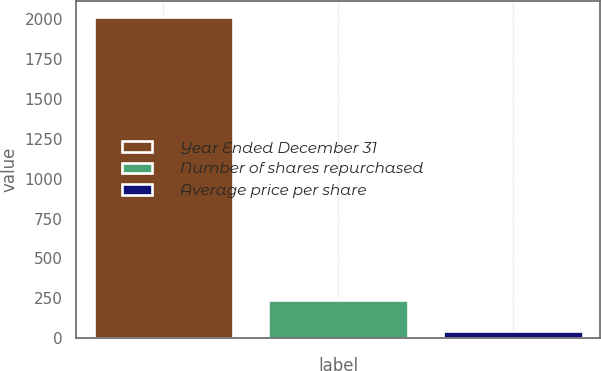<chart> <loc_0><loc_0><loc_500><loc_500><bar_chart><fcel>Year Ended December 31<fcel>Number of shares repurchased<fcel>Average price per share<nl><fcel>2017<fcel>241.38<fcel>44.09<nl></chart> 